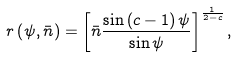Convert formula to latex. <formula><loc_0><loc_0><loc_500><loc_500>r \left ( \psi , \bar { n } \right ) = \left [ \bar { n } \frac { \sin \left ( c - 1 \right ) \psi } { \sin \psi } \right ] ^ { \frac { 1 } { 2 - c } } ,</formula> 